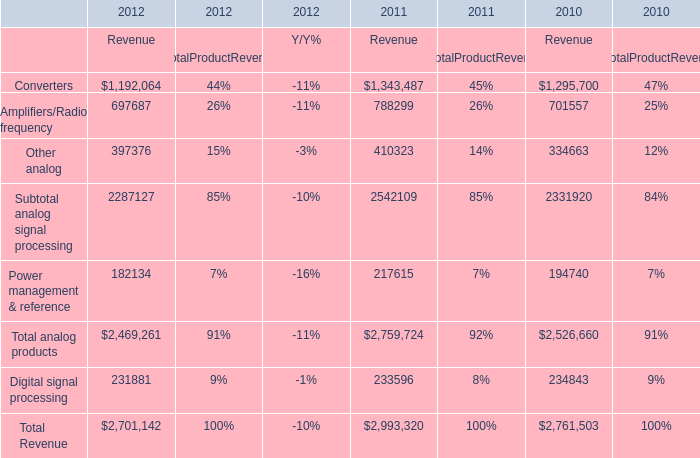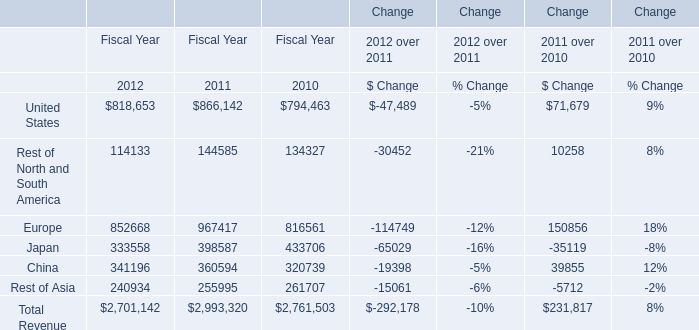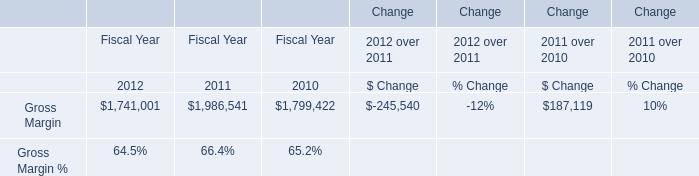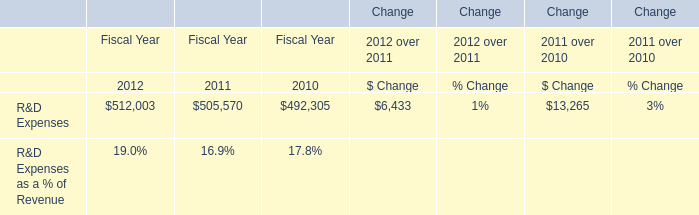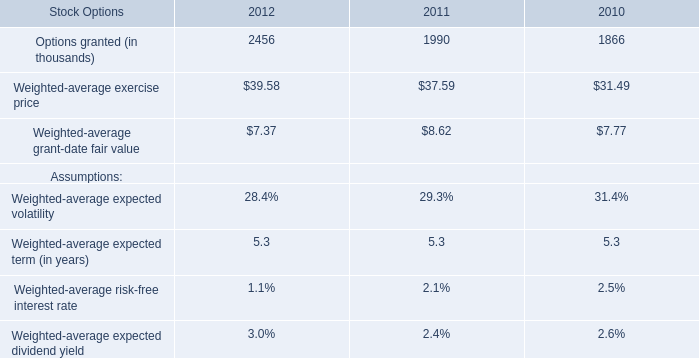What's the total amount of United States, Rest of North and South America, Europe and Japan in 2012? 
Computations: (((818653 + 114133) + 852668) + 333558)
Answer: 2119012.0. 